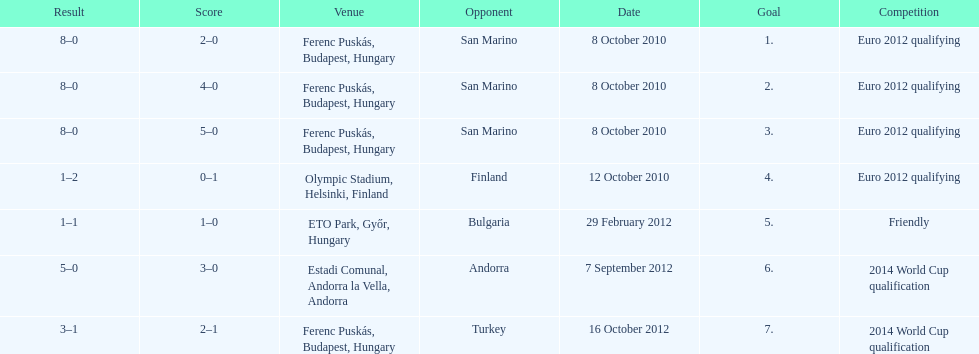How many goals were scored at the euro 2012 qualifying competition? 12. 